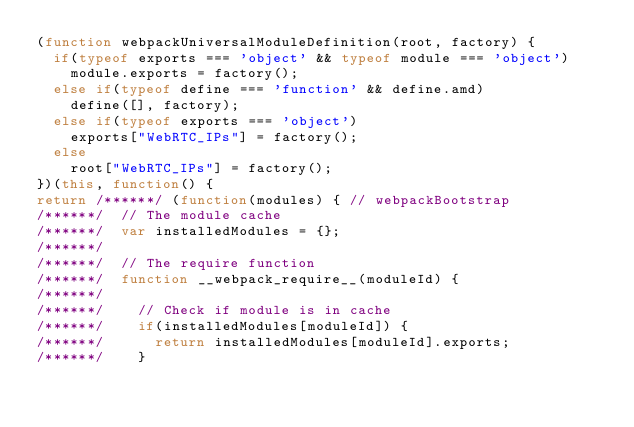Convert code to text. <code><loc_0><loc_0><loc_500><loc_500><_JavaScript_>(function webpackUniversalModuleDefinition(root, factory) {
	if(typeof exports === 'object' && typeof module === 'object')
		module.exports = factory();
	else if(typeof define === 'function' && define.amd)
		define([], factory);
	else if(typeof exports === 'object')
		exports["WebRTC_IPs"] = factory();
	else
		root["WebRTC_IPs"] = factory();
})(this, function() {
return /******/ (function(modules) { // webpackBootstrap
/******/ 	// The module cache
/******/ 	var installedModules = {};
/******/
/******/ 	// The require function
/******/ 	function __webpack_require__(moduleId) {
/******/
/******/ 		// Check if module is in cache
/******/ 		if(installedModules[moduleId]) {
/******/ 			return installedModules[moduleId].exports;
/******/ 		}</code> 